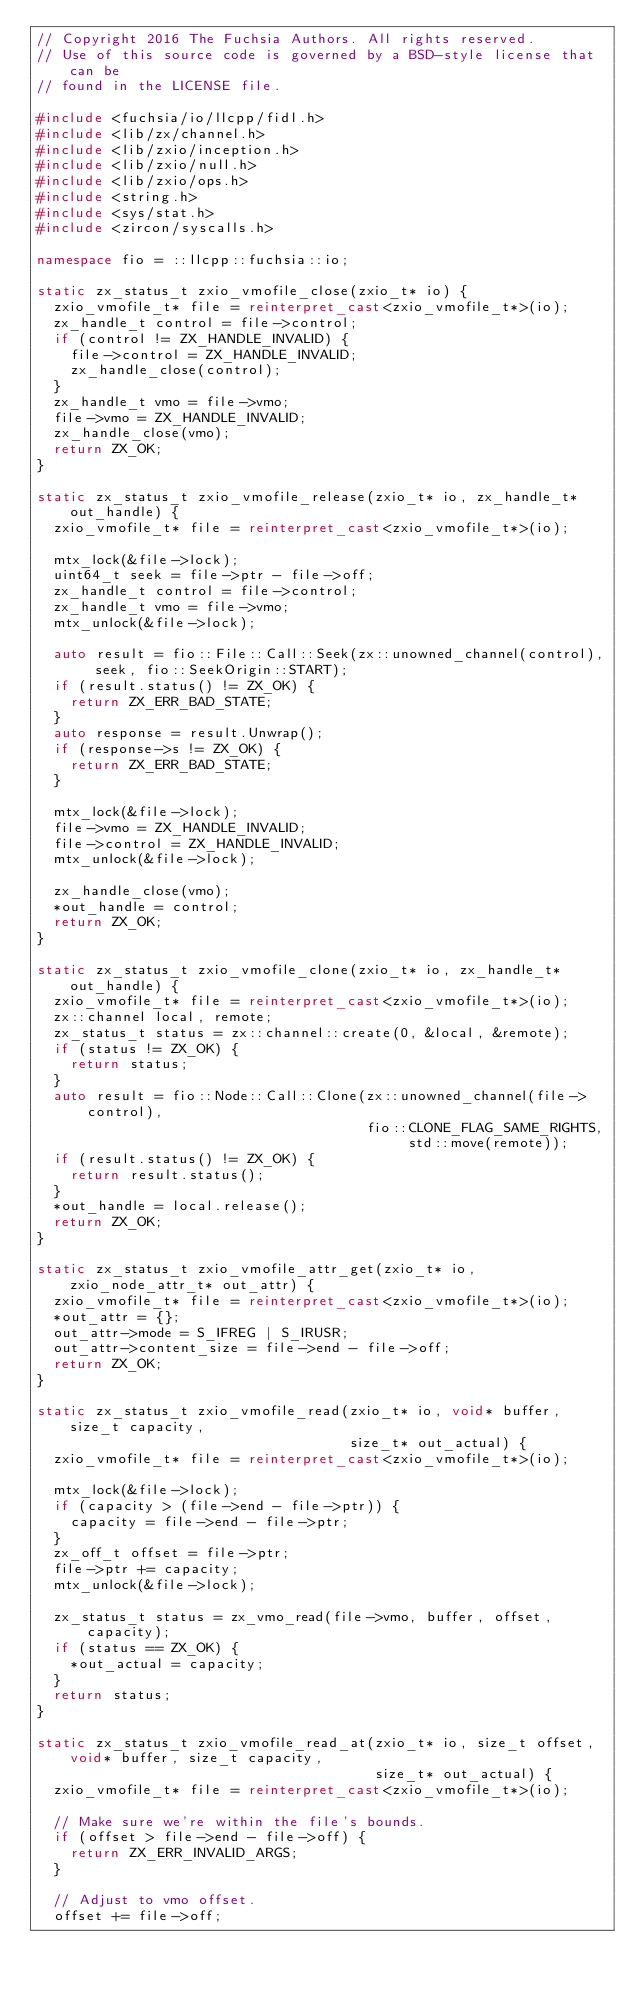Convert code to text. <code><loc_0><loc_0><loc_500><loc_500><_C++_>// Copyright 2016 The Fuchsia Authors. All rights reserved.
// Use of this source code is governed by a BSD-style license that can be
// found in the LICENSE file.

#include <fuchsia/io/llcpp/fidl.h>
#include <lib/zx/channel.h>
#include <lib/zxio/inception.h>
#include <lib/zxio/null.h>
#include <lib/zxio/ops.h>
#include <string.h>
#include <sys/stat.h>
#include <zircon/syscalls.h>

namespace fio = ::llcpp::fuchsia::io;

static zx_status_t zxio_vmofile_close(zxio_t* io) {
  zxio_vmofile_t* file = reinterpret_cast<zxio_vmofile_t*>(io);
  zx_handle_t control = file->control;
  if (control != ZX_HANDLE_INVALID) {
    file->control = ZX_HANDLE_INVALID;
    zx_handle_close(control);
  }
  zx_handle_t vmo = file->vmo;
  file->vmo = ZX_HANDLE_INVALID;
  zx_handle_close(vmo);
  return ZX_OK;
}

static zx_status_t zxio_vmofile_release(zxio_t* io, zx_handle_t* out_handle) {
  zxio_vmofile_t* file = reinterpret_cast<zxio_vmofile_t*>(io);

  mtx_lock(&file->lock);
  uint64_t seek = file->ptr - file->off;
  zx_handle_t control = file->control;
  zx_handle_t vmo = file->vmo;
  mtx_unlock(&file->lock);

  auto result = fio::File::Call::Seek(zx::unowned_channel(control), seek, fio::SeekOrigin::START);
  if (result.status() != ZX_OK) {
    return ZX_ERR_BAD_STATE;
  }
  auto response = result.Unwrap();
  if (response->s != ZX_OK) {
    return ZX_ERR_BAD_STATE;
  }

  mtx_lock(&file->lock);
  file->vmo = ZX_HANDLE_INVALID;
  file->control = ZX_HANDLE_INVALID;
  mtx_unlock(&file->lock);

  zx_handle_close(vmo);
  *out_handle = control;
  return ZX_OK;
}

static zx_status_t zxio_vmofile_clone(zxio_t* io, zx_handle_t* out_handle) {
  zxio_vmofile_t* file = reinterpret_cast<zxio_vmofile_t*>(io);
  zx::channel local, remote;
  zx_status_t status = zx::channel::create(0, &local, &remote);
  if (status != ZX_OK) {
    return status;
  }
  auto result = fio::Node::Call::Clone(zx::unowned_channel(file->control),
                                       fio::CLONE_FLAG_SAME_RIGHTS, std::move(remote));
  if (result.status() != ZX_OK) {
    return result.status();
  }
  *out_handle = local.release();
  return ZX_OK;
}

static zx_status_t zxio_vmofile_attr_get(zxio_t* io, zxio_node_attr_t* out_attr) {
  zxio_vmofile_t* file = reinterpret_cast<zxio_vmofile_t*>(io);
  *out_attr = {};
  out_attr->mode = S_IFREG | S_IRUSR;
  out_attr->content_size = file->end - file->off;
  return ZX_OK;
}

static zx_status_t zxio_vmofile_read(zxio_t* io, void* buffer, size_t capacity,
                                     size_t* out_actual) {
  zxio_vmofile_t* file = reinterpret_cast<zxio_vmofile_t*>(io);

  mtx_lock(&file->lock);
  if (capacity > (file->end - file->ptr)) {
    capacity = file->end - file->ptr;
  }
  zx_off_t offset = file->ptr;
  file->ptr += capacity;
  mtx_unlock(&file->lock);

  zx_status_t status = zx_vmo_read(file->vmo, buffer, offset, capacity);
  if (status == ZX_OK) {
    *out_actual = capacity;
  }
  return status;
}

static zx_status_t zxio_vmofile_read_at(zxio_t* io, size_t offset, void* buffer, size_t capacity,
                                        size_t* out_actual) {
  zxio_vmofile_t* file = reinterpret_cast<zxio_vmofile_t*>(io);

  // Make sure we're within the file's bounds.
  if (offset > file->end - file->off) {
    return ZX_ERR_INVALID_ARGS;
  }

  // Adjust to vmo offset.
  offset += file->off;
</code> 